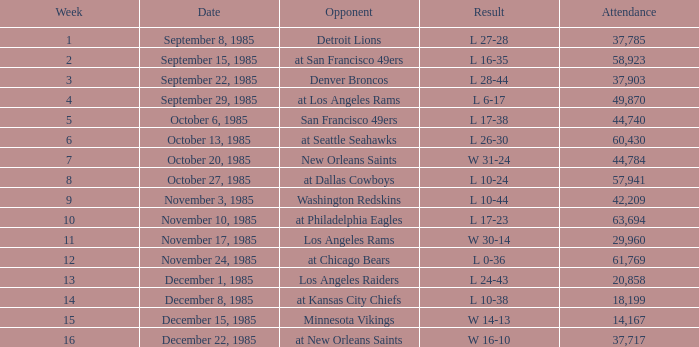Who was the opponent the falcons played against on week 3? Denver Broncos. 